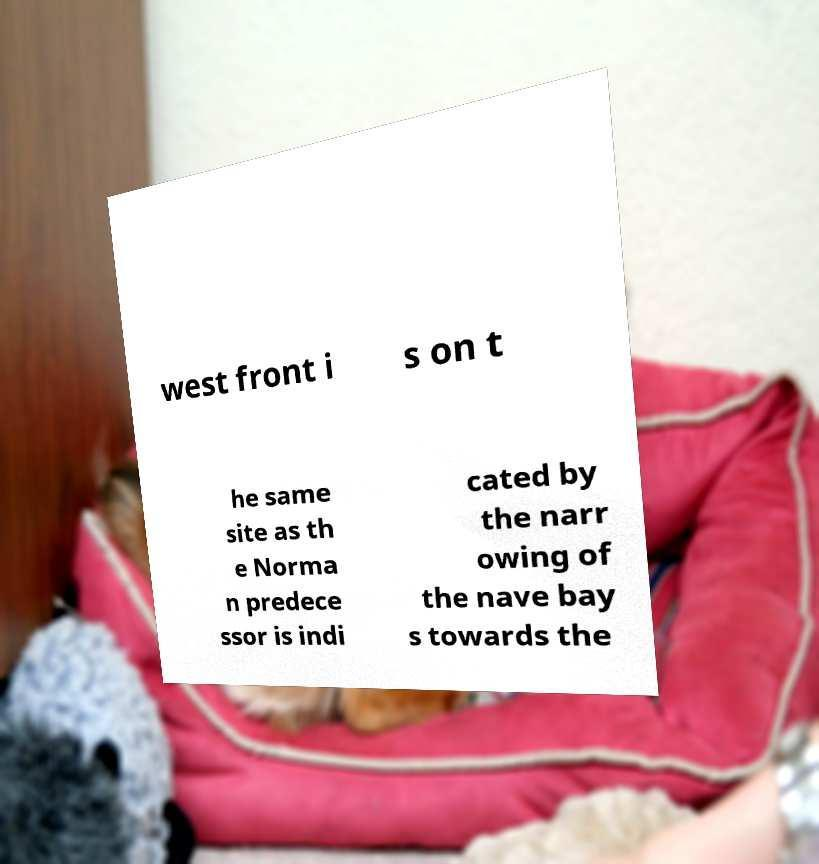Please identify and transcribe the text found in this image. west front i s on t he same site as th e Norma n predece ssor is indi cated by the narr owing of the nave bay s towards the 